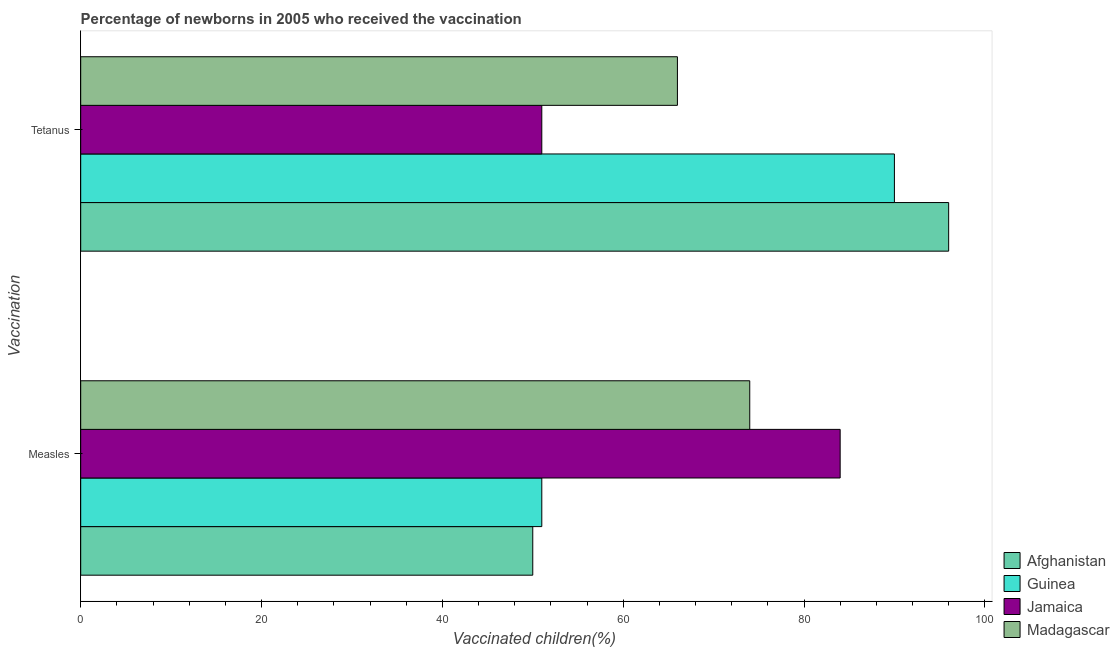Are the number of bars per tick equal to the number of legend labels?
Your answer should be very brief. Yes. How many bars are there on the 2nd tick from the top?
Provide a succinct answer. 4. How many bars are there on the 1st tick from the bottom?
Make the answer very short. 4. What is the label of the 1st group of bars from the top?
Offer a very short reply. Tetanus. What is the percentage of newborns who received vaccination for measles in Afghanistan?
Offer a very short reply. 50. Across all countries, what is the maximum percentage of newborns who received vaccination for measles?
Your answer should be compact. 84. Across all countries, what is the minimum percentage of newborns who received vaccination for tetanus?
Make the answer very short. 51. In which country was the percentage of newborns who received vaccination for measles maximum?
Provide a short and direct response. Jamaica. In which country was the percentage of newborns who received vaccination for measles minimum?
Provide a succinct answer. Afghanistan. What is the total percentage of newborns who received vaccination for tetanus in the graph?
Make the answer very short. 303. What is the difference between the percentage of newborns who received vaccination for tetanus in Guinea and that in Afghanistan?
Your answer should be compact. -6. What is the difference between the percentage of newborns who received vaccination for tetanus in Guinea and the percentage of newborns who received vaccination for measles in Afghanistan?
Offer a terse response. 40. What is the average percentage of newborns who received vaccination for measles per country?
Provide a succinct answer. 64.75. What is the difference between the percentage of newborns who received vaccination for measles and percentage of newborns who received vaccination for tetanus in Afghanistan?
Keep it short and to the point. -46. What is the ratio of the percentage of newborns who received vaccination for measles in Afghanistan to that in Jamaica?
Your response must be concise. 0.6. In how many countries, is the percentage of newborns who received vaccination for tetanus greater than the average percentage of newborns who received vaccination for tetanus taken over all countries?
Keep it short and to the point. 2. What does the 2nd bar from the top in Measles represents?
Provide a succinct answer. Jamaica. What does the 4th bar from the bottom in Measles represents?
Give a very brief answer. Madagascar. How many bars are there?
Keep it short and to the point. 8. Does the graph contain grids?
Your response must be concise. No. How many legend labels are there?
Ensure brevity in your answer.  4. What is the title of the graph?
Your answer should be compact. Percentage of newborns in 2005 who received the vaccination. What is the label or title of the X-axis?
Make the answer very short. Vaccinated children(%)
. What is the label or title of the Y-axis?
Offer a very short reply. Vaccination. What is the Vaccinated children(%)
 in Guinea in Measles?
Your response must be concise. 51. What is the Vaccinated children(%)
 of Jamaica in Measles?
Give a very brief answer. 84. What is the Vaccinated children(%)
 in Madagascar in Measles?
Keep it short and to the point. 74. What is the Vaccinated children(%)
 of Afghanistan in Tetanus?
Your response must be concise. 96. What is the Vaccinated children(%)
 in Madagascar in Tetanus?
Offer a terse response. 66. Across all Vaccination, what is the maximum Vaccinated children(%)
 in Afghanistan?
Your answer should be very brief. 96. Across all Vaccination, what is the minimum Vaccinated children(%)
 in Afghanistan?
Provide a short and direct response. 50. Across all Vaccination, what is the minimum Vaccinated children(%)
 in Jamaica?
Ensure brevity in your answer.  51. What is the total Vaccinated children(%)
 of Afghanistan in the graph?
Your answer should be compact. 146. What is the total Vaccinated children(%)
 of Guinea in the graph?
Your answer should be compact. 141. What is the total Vaccinated children(%)
 in Jamaica in the graph?
Offer a terse response. 135. What is the total Vaccinated children(%)
 in Madagascar in the graph?
Offer a very short reply. 140. What is the difference between the Vaccinated children(%)
 in Afghanistan in Measles and that in Tetanus?
Offer a very short reply. -46. What is the difference between the Vaccinated children(%)
 in Guinea in Measles and that in Tetanus?
Keep it short and to the point. -39. What is the difference between the Vaccinated children(%)
 of Madagascar in Measles and that in Tetanus?
Provide a short and direct response. 8. What is the difference between the Vaccinated children(%)
 of Afghanistan in Measles and the Vaccinated children(%)
 of Guinea in Tetanus?
Provide a short and direct response. -40. What is the difference between the Vaccinated children(%)
 of Afghanistan in Measles and the Vaccinated children(%)
 of Jamaica in Tetanus?
Provide a short and direct response. -1. What is the difference between the Vaccinated children(%)
 in Guinea in Measles and the Vaccinated children(%)
 in Madagascar in Tetanus?
Offer a very short reply. -15. What is the average Vaccinated children(%)
 in Afghanistan per Vaccination?
Provide a succinct answer. 73. What is the average Vaccinated children(%)
 in Guinea per Vaccination?
Offer a terse response. 70.5. What is the average Vaccinated children(%)
 of Jamaica per Vaccination?
Give a very brief answer. 67.5. What is the average Vaccinated children(%)
 in Madagascar per Vaccination?
Make the answer very short. 70. What is the difference between the Vaccinated children(%)
 in Afghanistan and Vaccinated children(%)
 in Jamaica in Measles?
Offer a very short reply. -34. What is the difference between the Vaccinated children(%)
 of Afghanistan and Vaccinated children(%)
 of Madagascar in Measles?
Offer a very short reply. -24. What is the difference between the Vaccinated children(%)
 in Guinea and Vaccinated children(%)
 in Jamaica in Measles?
Your response must be concise. -33. What is the difference between the Vaccinated children(%)
 in Guinea and Vaccinated children(%)
 in Madagascar in Measles?
Give a very brief answer. -23. What is the difference between the Vaccinated children(%)
 of Afghanistan and Vaccinated children(%)
 of Guinea in Tetanus?
Offer a very short reply. 6. What is the difference between the Vaccinated children(%)
 in Guinea and Vaccinated children(%)
 in Jamaica in Tetanus?
Keep it short and to the point. 39. What is the difference between the Vaccinated children(%)
 in Guinea and Vaccinated children(%)
 in Madagascar in Tetanus?
Provide a short and direct response. 24. What is the difference between the Vaccinated children(%)
 in Jamaica and Vaccinated children(%)
 in Madagascar in Tetanus?
Your response must be concise. -15. What is the ratio of the Vaccinated children(%)
 in Afghanistan in Measles to that in Tetanus?
Make the answer very short. 0.52. What is the ratio of the Vaccinated children(%)
 of Guinea in Measles to that in Tetanus?
Offer a very short reply. 0.57. What is the ratio of the Vaccinated children(%)
 of Jamaica in Measles to that in Tetanus?
Keep it short and to the point. 1.65. What is the ratio of the Vaccinated children(%)
 in Madagascar in Measles to that in Tetanus?
Your response must be concise. 1.12. What is the difference between the highest and the second highest Vaccinated children(%)
 of Afghanistan?
Your response must be concise. 46. What is the difference between the highest and the second highest Vaccinated children(%)
 of Jamaica?
Make the answer very short. 33. What is the difference between the highest and the lowest Vaccinated children(%)
 of Madagascar?
Ensure brevity in your answer.  8. 